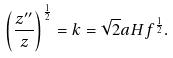<formula> <loc_0><loc_0><loc_500><loc_500>\left ( \frac { z ^ { \prime \prime } } { z } \right ) ^ { \frac { 1 } { 2 } } = k = \sqrt { 2 } a H f ^ { \frac { 1 } { 2 } } .</formula> 